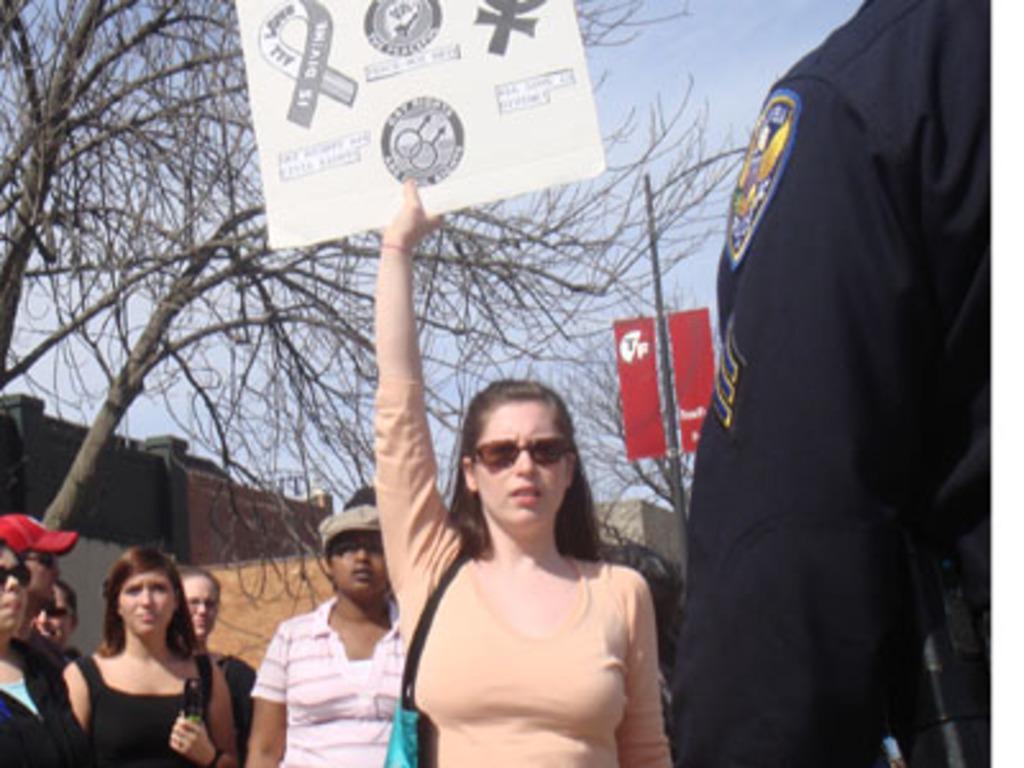Describe this image in one or two sentences. In this image I can see there are few peoples visible and a woman holding a boat, on the board there are symbols visible, back side of persons I can see a pole, trees and the wall and the sky. 